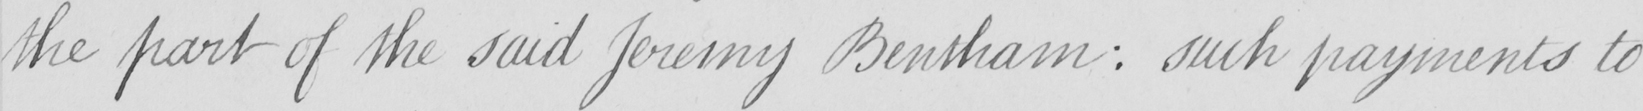Transcribe the text shown in this historical manuscript line. the part of the said Jeremy Bentham :  such payments to 